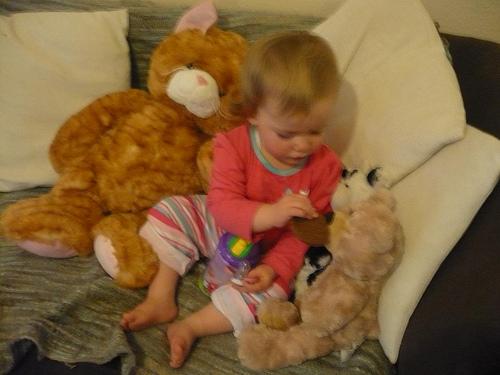How many toys are next to the baby?
Be succinct. 3. Does this kid look happy?
Quick response, please. Yes. What is on the child's shirt?
Keep it brief. Pink color. What is the girl doing?
Write a very short answer. Playing. What are the teddy bears sitting in?
Quick response, please. Bed. Do you see a ribbon?
Be succinct. No. What is the person wearing on their feet?
Be succinct. Nothing. How many bears are there?
Be succinct. 2. Is this a holiday stuffed animal?
Concise answer only. No. Does this baby like her toys?
Give a very brief answer. Yes. What kind of stuffed animal is to the left of the child?
Answer briefly. Bear. What car is the baby's shirt?
Give a very brief answer. Pink. What food is in his hand?
Answer briefly. Cookie. What color is the bear?
Write a very short answer. Brown. What is the kid holding?
Keep it brief. Cookie. What color is the baby's shirt?
Answer briefly. Pink. How many pillows are on the bed?
Answer briefly. 3. What is on the wrist?
Write a very short answer. Nothing. Which bear is darker?
Concise answer only. Left. Is the baby sleeping?
Write a very short answer. No. Can the bear's tail be seen?
Be succinct. No. What color is the baby's hair?
Give a very brief answer. Blonde. What color hair does the baby have?
Answer briefly. Blonde. What is the bear doing?
Answer briefly. Sitting. Is she holding the bear?
Short answer required. No. Does the baby like the teddy bear?
Short answer required. Yes. 